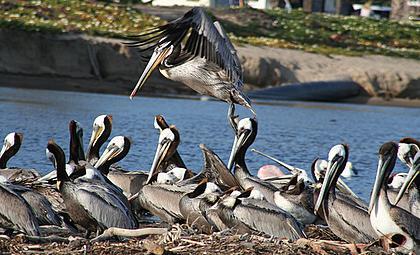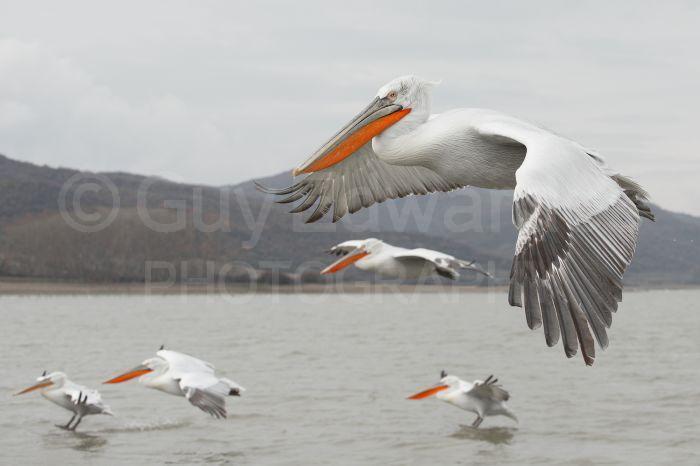The first image is the image on the left, the second image is the image on the right. For the images displayed, is the sentence "At least one bird is flying." factually correct? Answer yes or no. Yes. The first image is the image on the left, the second image is the image on the right. For the images shown, is this caption "there is a flying bird in the image on the right" true? Answer yes or no. Yes. 